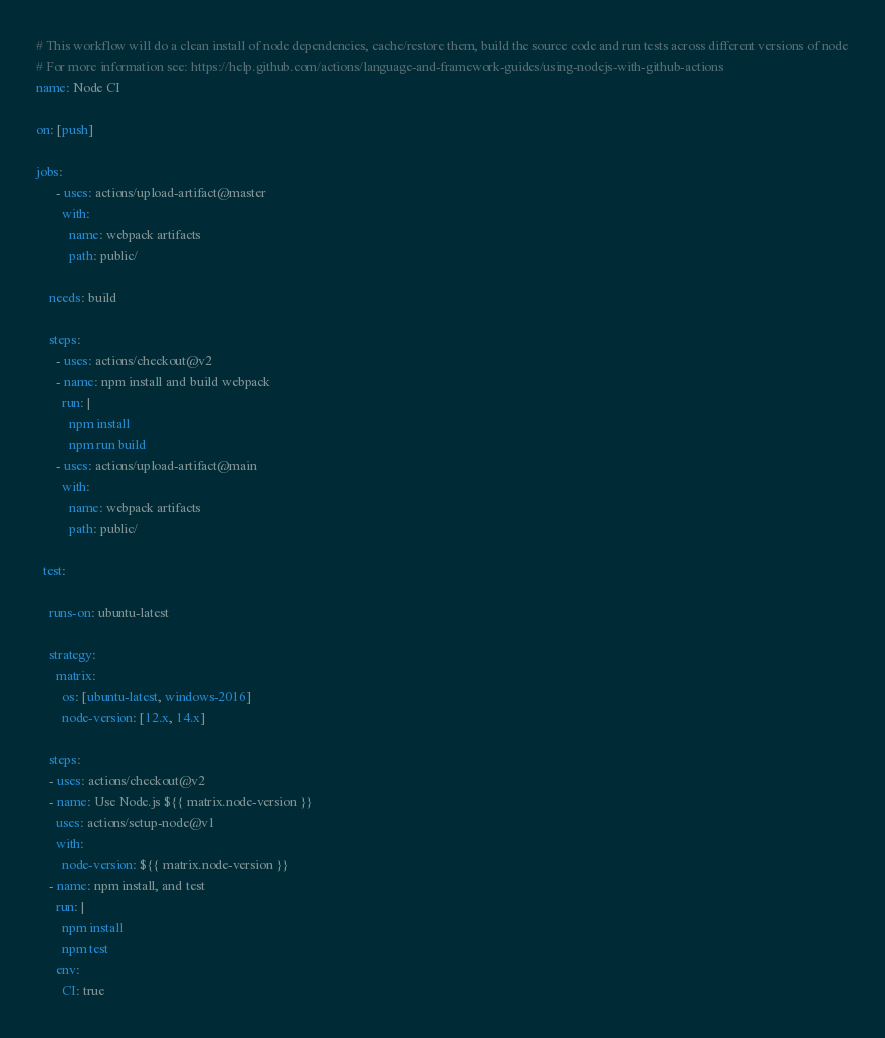<code> <loc_0><loc_0><loc_500><loc_500><_YAML_># This workflow will do a clean install of node dependencies, cache/restore them, build the source code and run tests across different versions of node
# For more information see: https://help.github.com/actions/language-and-framework-guides/using-nodejs-with-github-actions
name: Node CI

on: [push]

jobs:
      - uses: actions/upload-artifact@master
        with:
          name: webpack artifacts
          path: public/

    needs: build

    steps:
      - uses: actions/checkout@v2
      - name: npm install and build webpack
        run: |
          npm install
          npm run build
      - uses: actions/upload-artifact@main
        with:
          name: webpack artifacts
          path: public/

  test:

    runs-on: ubuntu-latest

    strategy:
      matrix:
        os: [ubuntu-latest, windows-2016]
        node-version: [12.x, 14.x]

    steps:
    - uses: actions/checkout@v2
    - name: Use Node.js ${{ matrix.node-version }}
      uses: actions/setup-node@v1
      with:
        node-version: ${{ matrix.node-version }}
    - name: npm install, and test
      run: |
        npm install
        npm test
      env:
        CI: true
</code> 